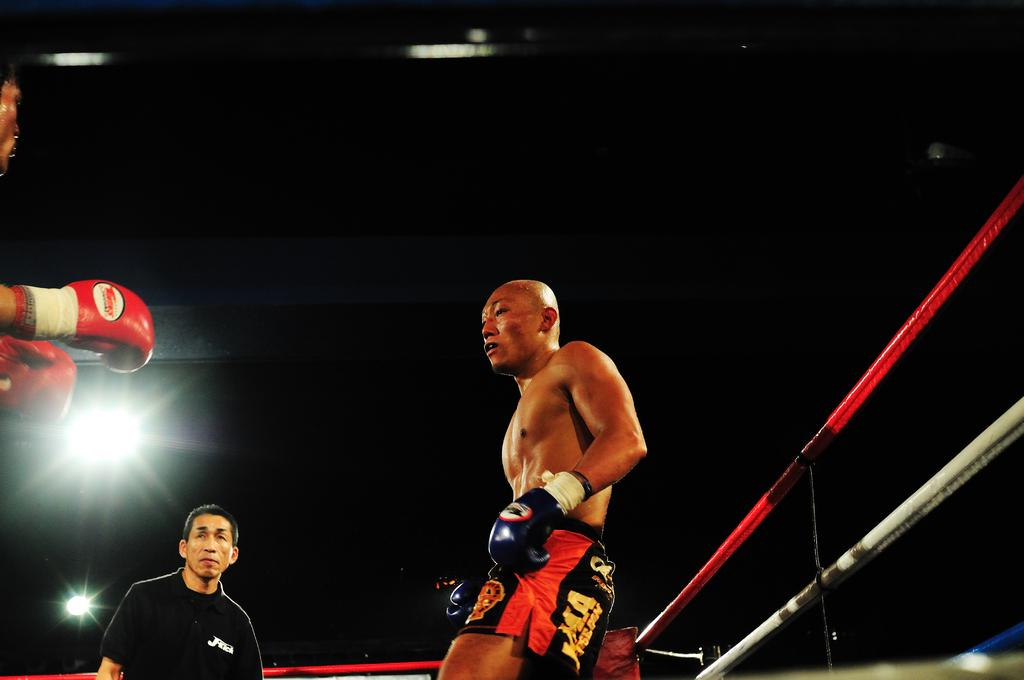<image>
Present a compact description of the photo's key features. a boxer in red and black shorts displaying JMA 